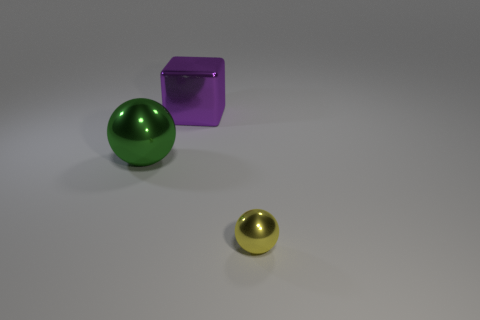Do the green metal object and the purple shiny block have the same size?
Offer a terse response. Yes. What number of things are either yellow rubber blocks or big purple blocks?
Keep it short and to the point. 1. What is the shape of the big metallic object that is right of the large thing in front of the big thing that is behind the green sphere?
Make the answer very short. Cube. Is the material of the big thing that is behind the large ball the same as the sphere that is behind the yellow metallic sphere?
Offer a terse response. Yes. There is a yellow thing that is the same shape as the green metal object; what is its material?
Provide a short and direct response. Metal. Are there any other things that are the same size as the yellow ball?
Keep it short and to the point. No. Does the large object that is behind the large green metal thing have the same shape as the metallic thing in front of the large green object?
Provide a short and direct response. No. Is the number of green spheres in front of the large green ball less than the number of big purple metal cubes to the right of the small yellow metallic sphere?
Make the answer very short. No. What number of other objects are the same shape as the big green metallic object?
Provide a short and direct response. 1. What shape is the other tiny thing that is made of the same material as the purple thing?
Make the answer very short. Sphere. 